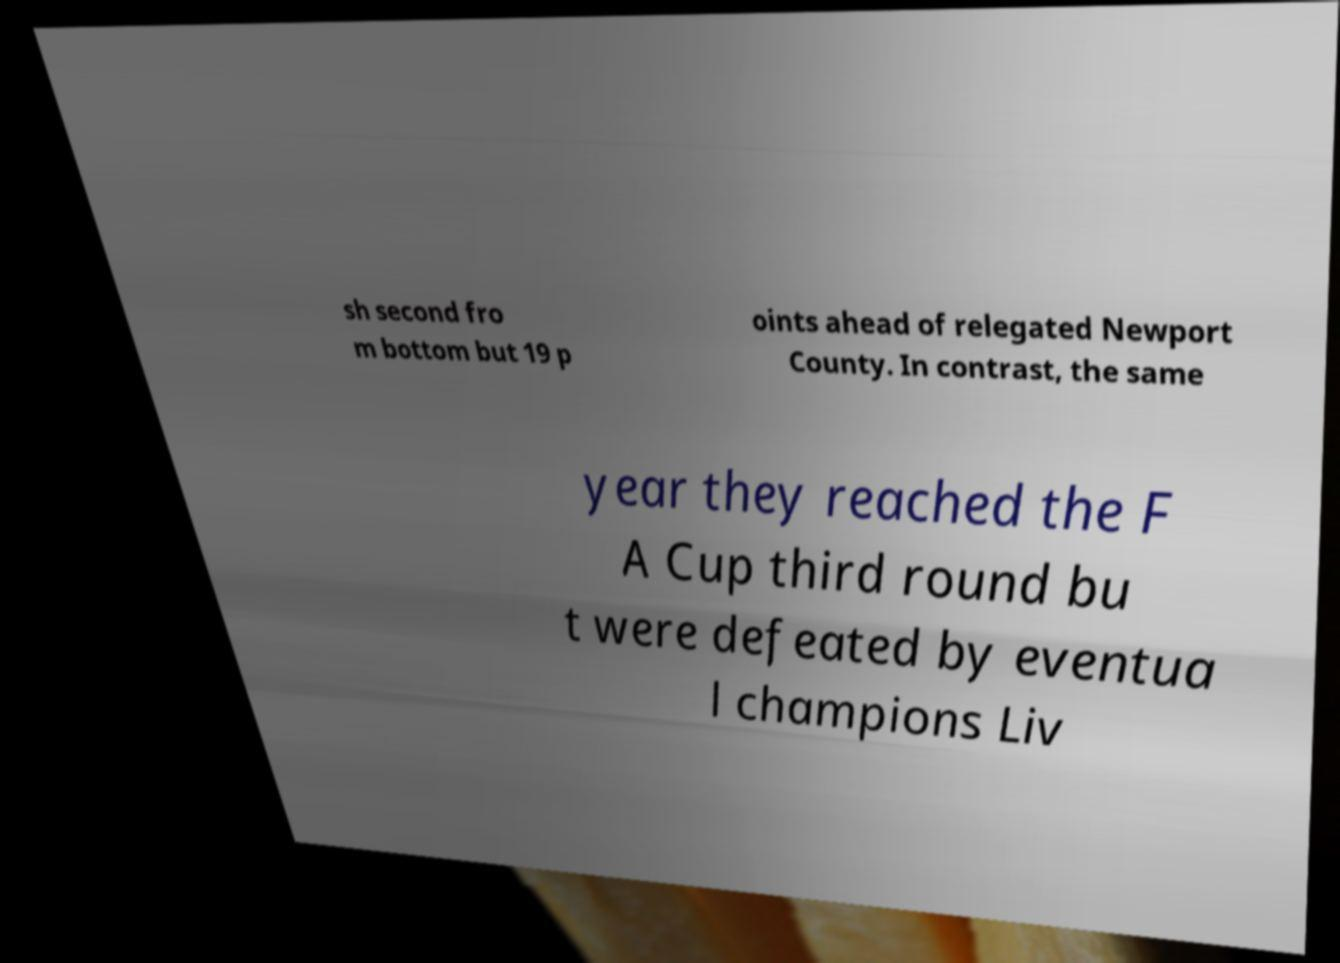Please identify and transcribe the text found in this image. sh second fro m bottom but 19 p oints ahead of relegated Newport County. In contrast, the same year they reached the F A Cup third round bu t were defeated by eventua l champions Liv 